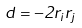Convert formula to latex. <formula><loc_0><loc_0><loc_500><loc_500>d = - 2 r _ { i } r _ { j }</formula> 